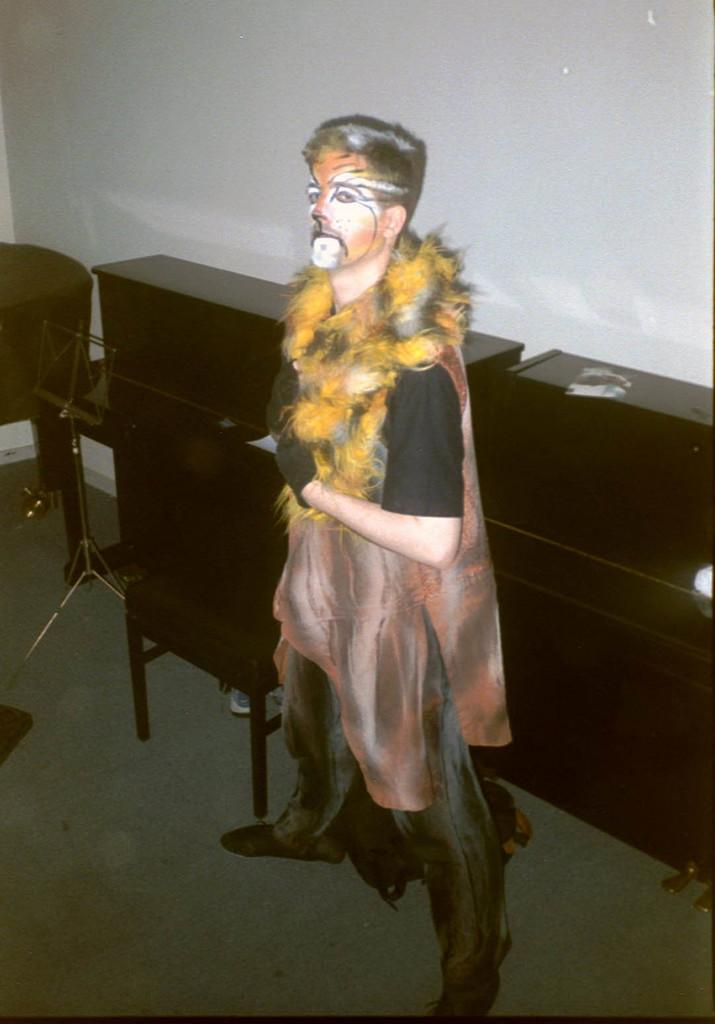Who is present in the image? There is a person in the image. What is the person wearing? The person is wearing a costume. What color are the objects in the image? The objects in the image are brown-colored. What can be seen beneath the person's feet? The floor is visible in the image. What is the color of the wall in the background? There is a white wall in the background of the image. How many credits can be seen on the person's costume in the image? There are no credits visible on the person's costume in the image. 